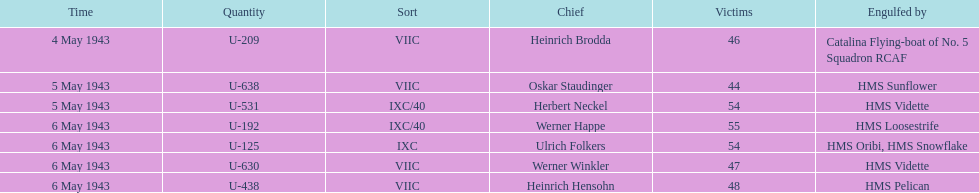Which u-boat was the first to sink U-209. 